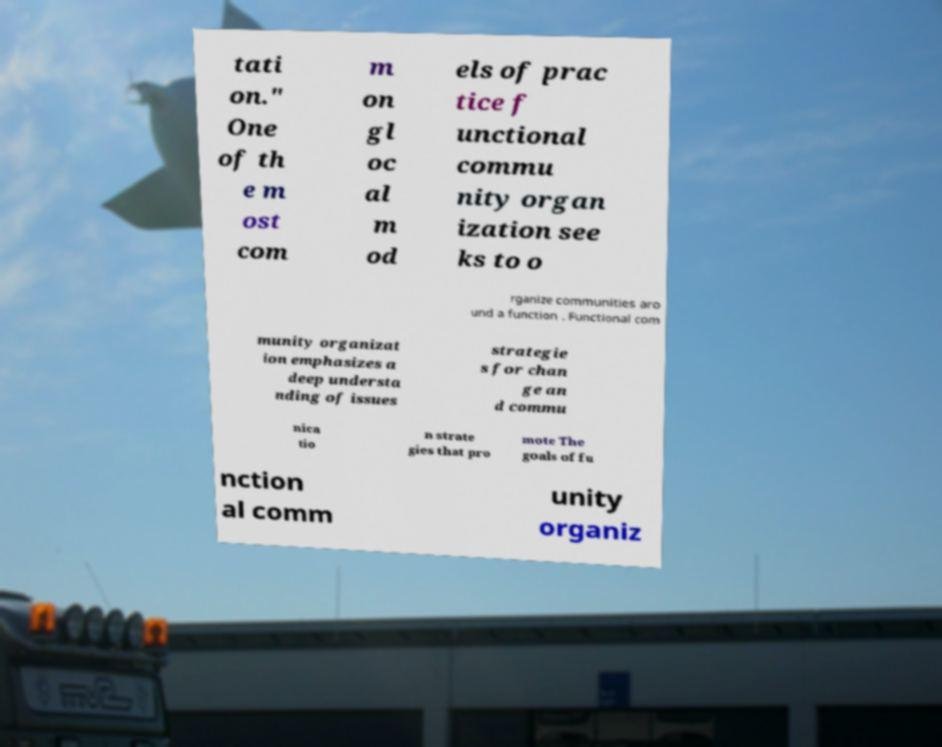Can you read and provide the text displayed in the image?This photo seems to have some interesting text. Can you extract and type it out for me? tati on." One of th e m ost com m on gl oc al m od els of prac tice f unctional commu nity organ ization see ks to o rganize communities aro und a function . Functional com munity organizat ion emphasizes a deep understa nding of issues strategie s for chan ge an d commu nica tio n strate gies that pro mote The goals of fu nction al comm unity organiz 